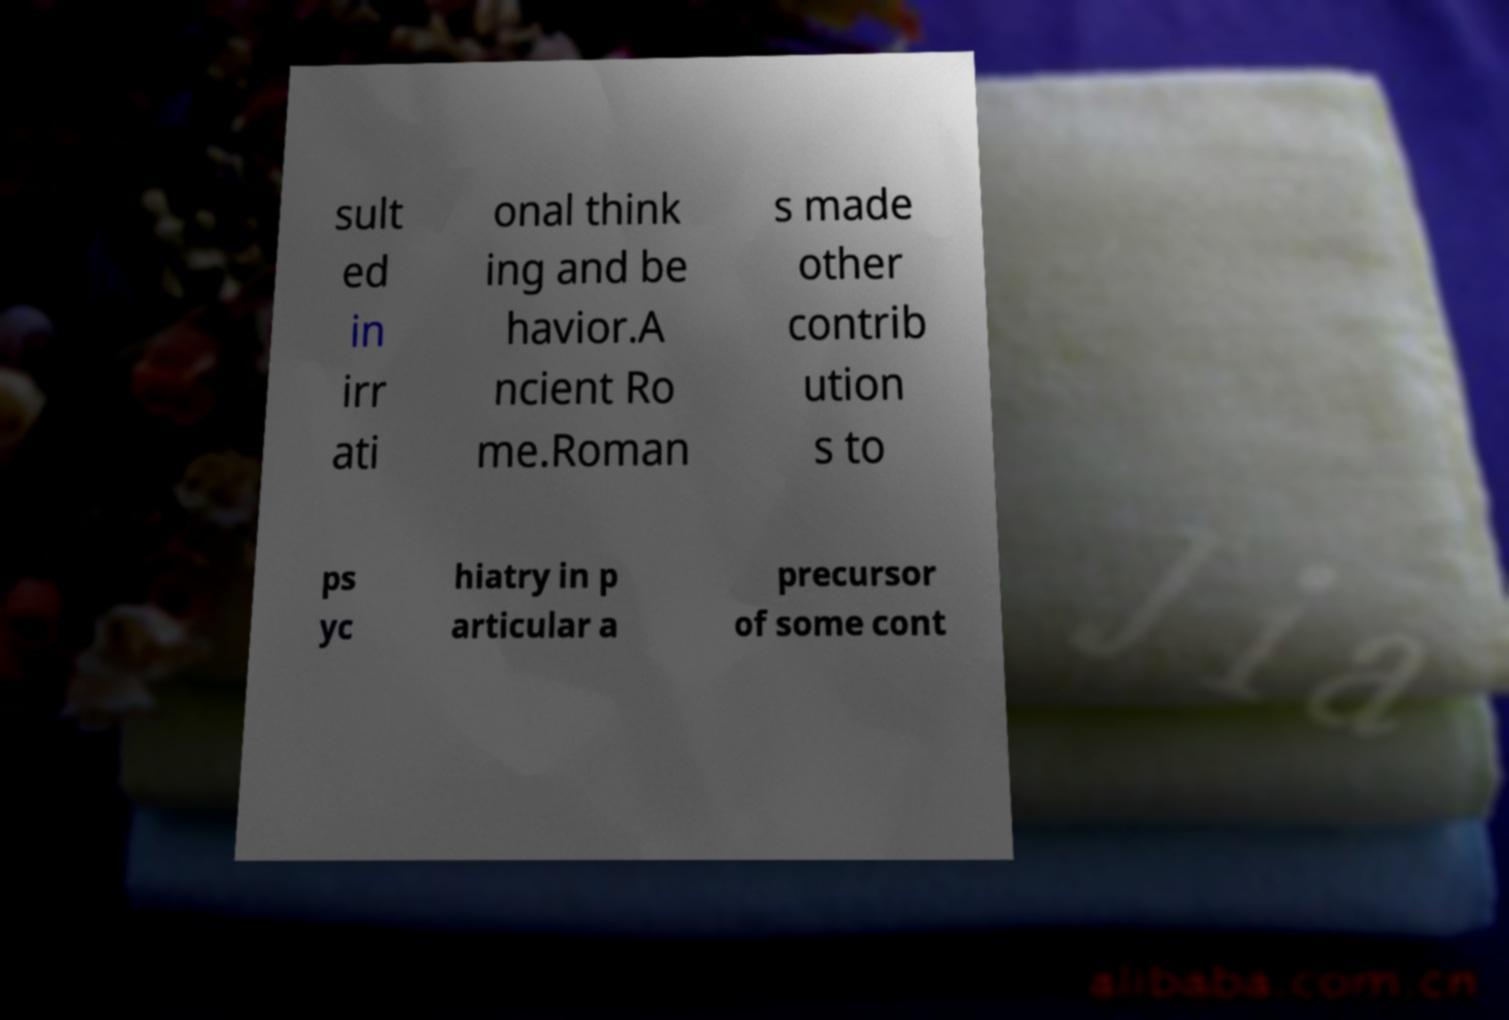Can you accurately transcribe the text from the provided image for me? sult ed in irr ati onal think ing and be havior.A ncient Ro me.Roman s made other contrib ution s to ps yc hiatry in p articular a precursor of some cont 